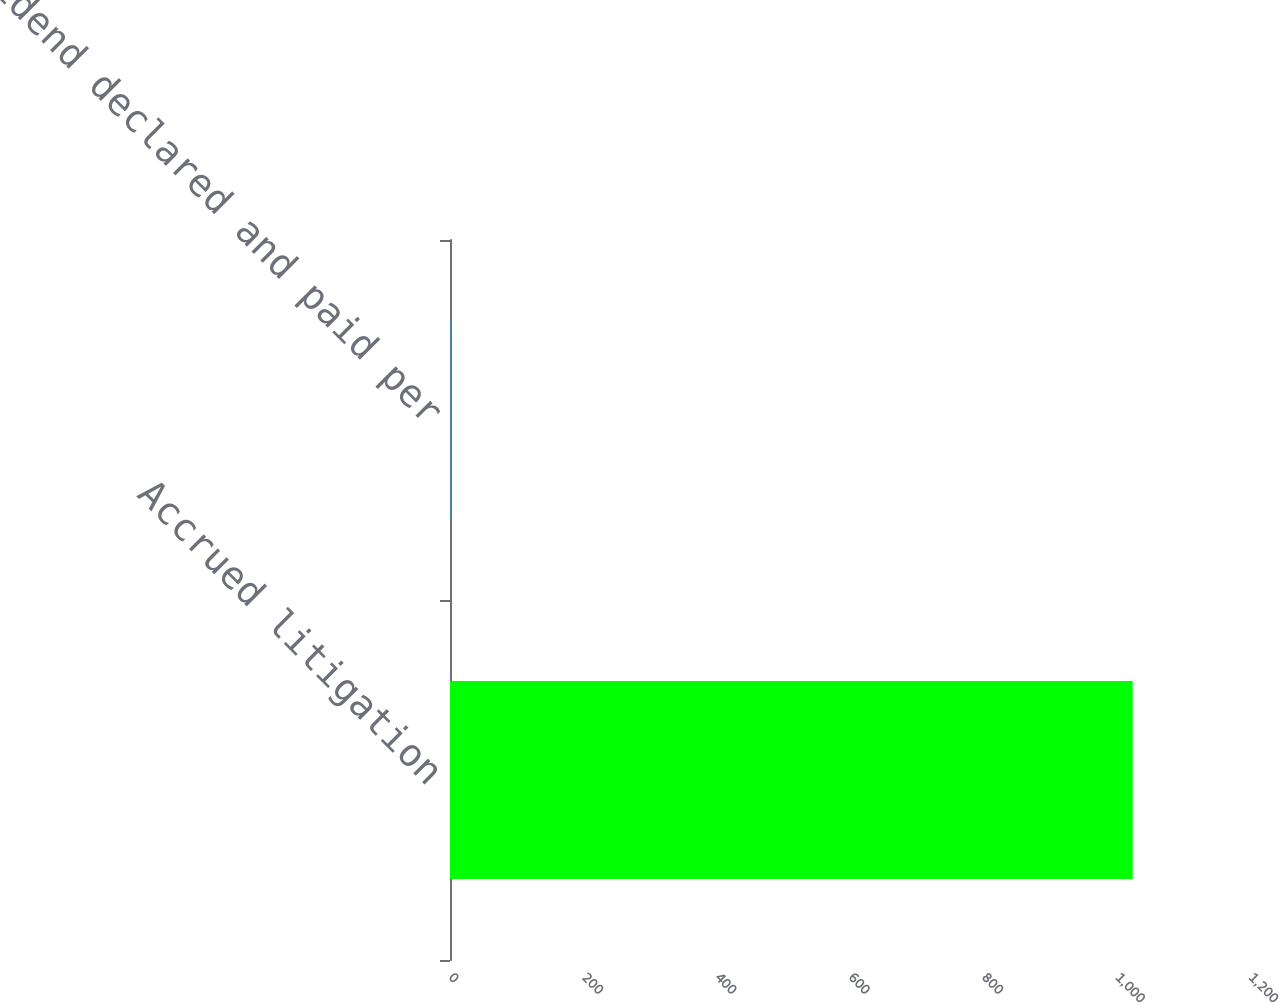<chart> <loc_0><loc_0><loc_500><loc_500><bar_chart><fcel>Accrued litigation<fcel>Dividend declared and paid per<nl><fcel>1024<fcel>0.48<nl></chart> 